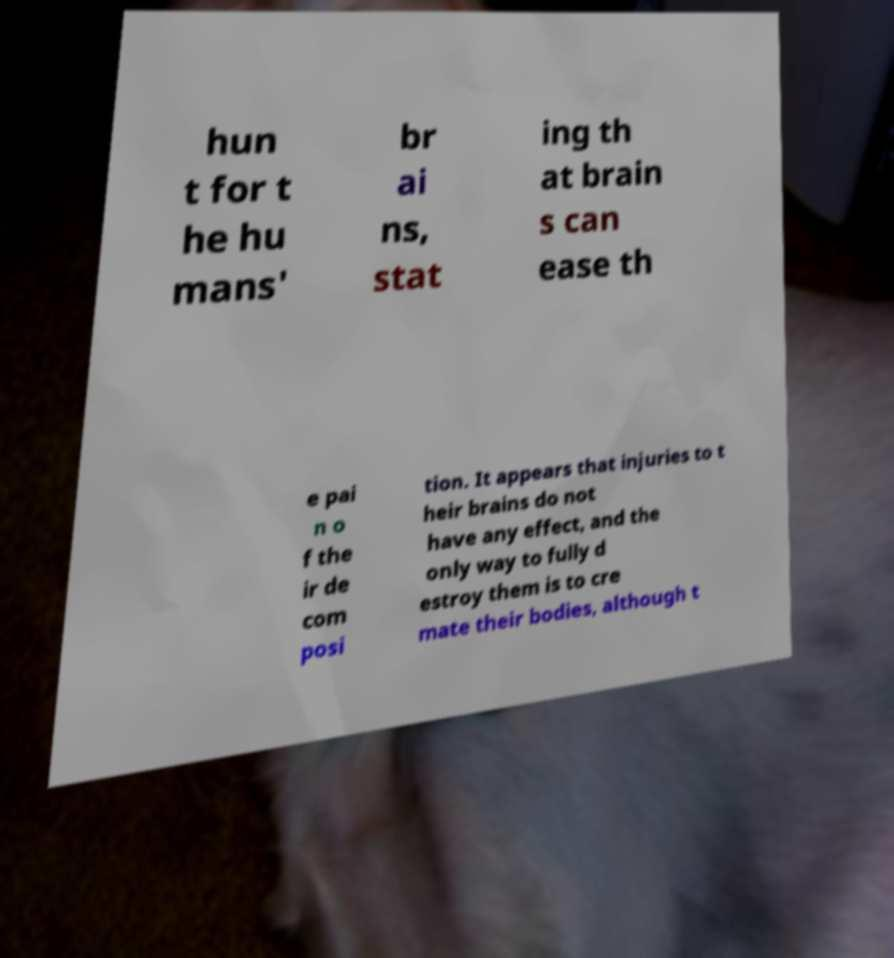Please read and relay the text visible in this image. What does it say? hun t for t he hu mans' br ai ns, stat ing th at brain s can ease th e pai n o f the ir de com posi tion. It appears that injuries to t heir brains do not have any effect, and the only way to fully d estroy them is to cre mate their bodies, although t 